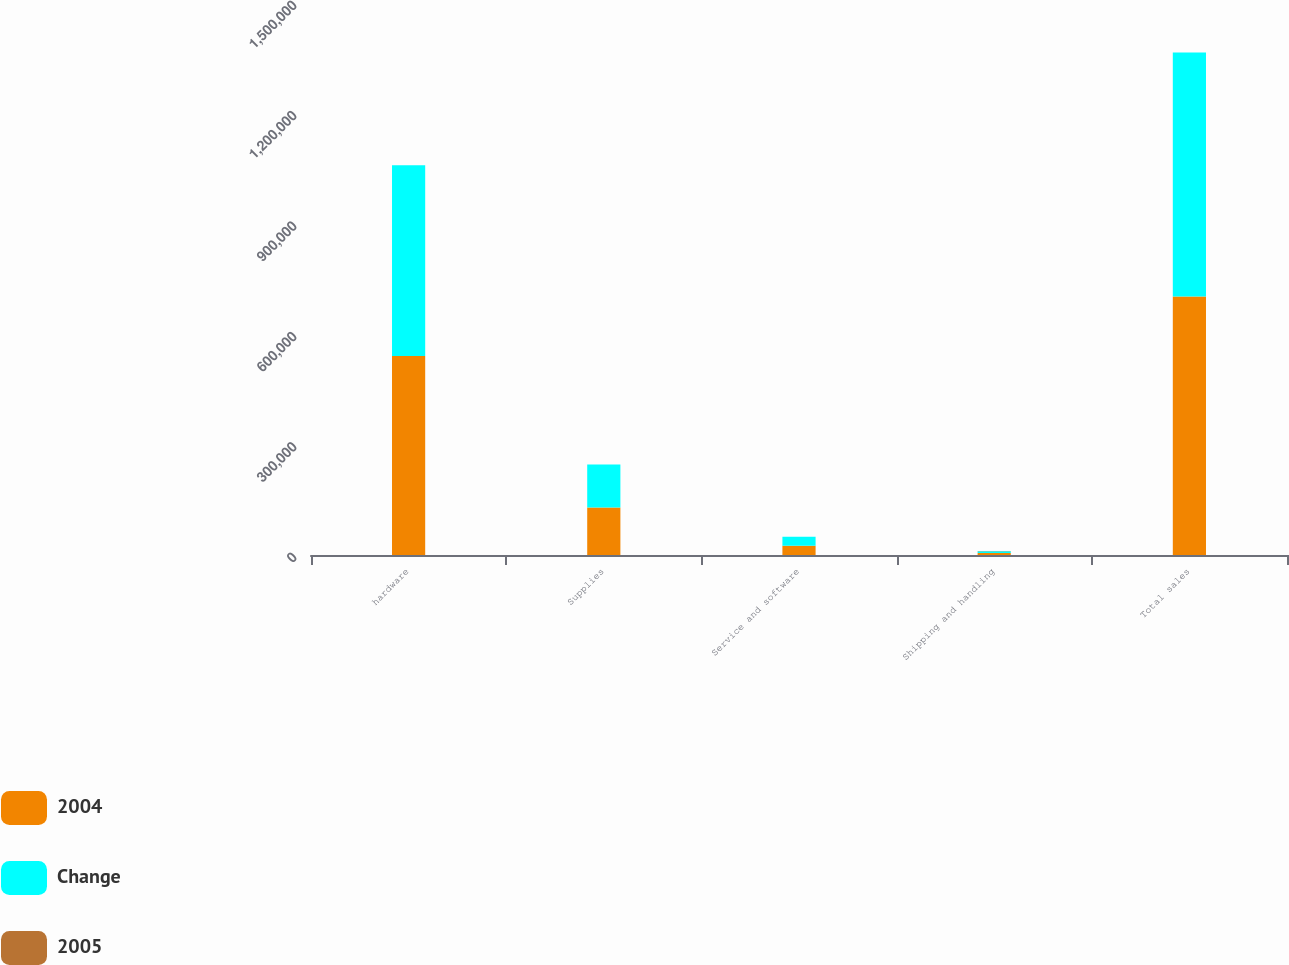Convert chart. <chart><loc_0><loc_0><loc_500><loc_500><stacked_bar_chart><ecel><fcel>hardware<fcel>Supplies<fcel>Service and software<fcel>Shipping and handling<fcel>Total sales<nl><fcel>2004<fcel>540679<fcel>129183<fcel>25217<fcel>5575<fcel>702271<nl><fcel>Change<fcel>518556<fcel>116877<fcel>24310<fcel>4950<fcel>663054<nl><fcel>2005<fcel>4.3<fcel>10.5<fcel>3.7<fcel>12.6<fcel>5.9<nl></chart> 